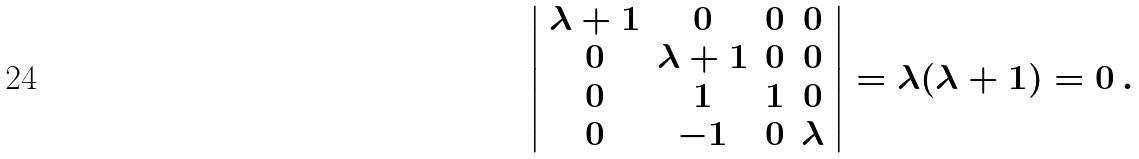<formula> <loc_0><loc_0><loc_500><loc_500>\left | \begin{array} { c c c c } \lambda + 1 & 0 & 0 & 0 \\ 0 & \lambda + 1 & 0 & 0 \\ 0 & 1 & 1 & 0 \\ 0 & - 1 & 0 & \lambda \end{array} \right | = \lambda ( \lambda + 1 ) = 0 \, .</formula> 